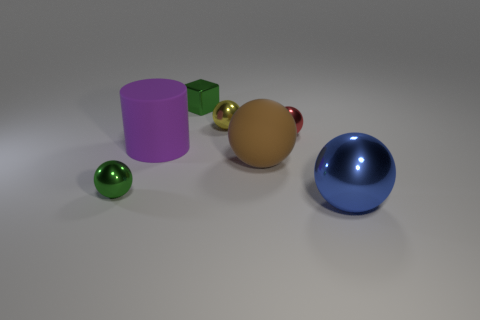How is the lighting in this scene affecting the appearance of the objects? The scene appears to be lit by a diffuse overhead light source, giving the objects soft shadows that gently stretch away from them. The reflective surfaces of the sphere and hemisphere clearly show the white highlights, pointing to the direction of the light. This diffuse lighting enhances the dimensionality of each object, revealing their contours and textures without harsh contrasts.  Are there any elements in this image that suggest it might not be a real-life photograph? Yes, a few clues suggest this is a computer-generated rendering rather than a photograph. The perfect cleanliness of the objects, the absence of imperfections, and the uniformity of the shadows and lighting are telltale signs of a digital creation. Real-world objects typically carry some degree of wear or irregularity, and lighting conditions are usually more complex. 